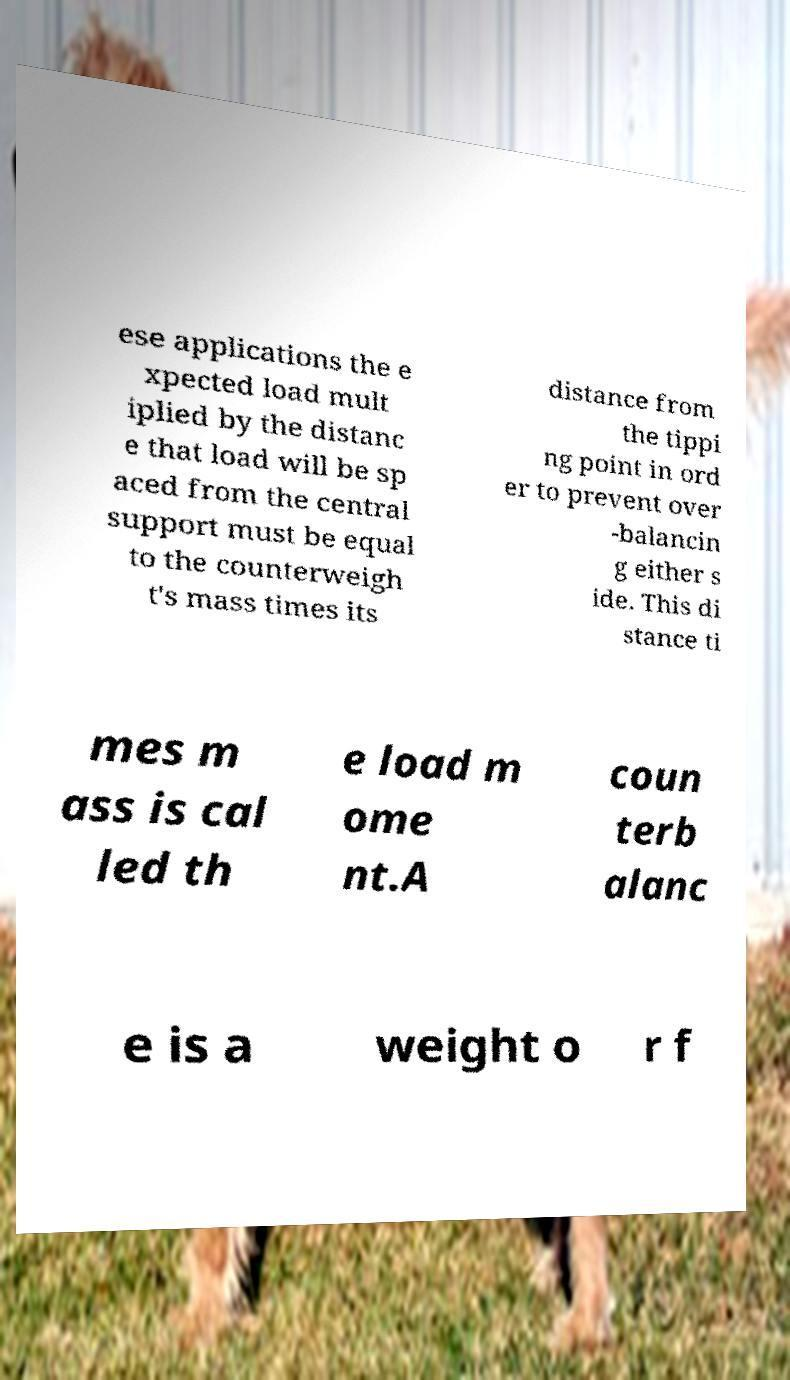Please identify and transcribe the text found in this image. ese applications the e xpected load mult iplied by the distanc e that load will be sp aced from the central support must be equal to the counterweigh t's mass times its distance from the tippi ng point in ord er to prevent over -balancin g either s ide. This di stance ti mes m ass is cal led th e load m ome nt.A coun terb alanc e is a weight o r f 